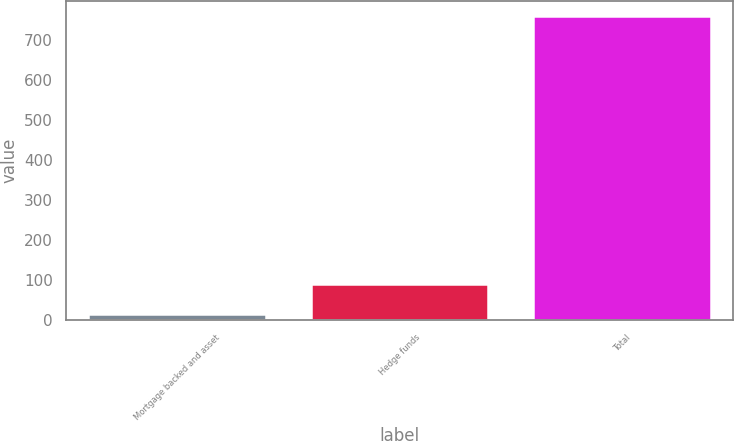Convert chart to OTSL. <chart><loc_0><loc_0><loc_500><loc_500><bar_chart><fcel>Mortgage backed and asset<fcel>Hedge funds<fcel>Total<nl><fcel>14<fcel>88.7<fcel>761<nl></chart> 